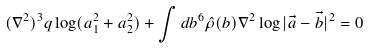<formula> <loc_0><loc_0><loc_500><loc_500>( \nabla ^ { 2 } ) ^ { 3 } q \log ( a _ { 1 } ^ { 2 } + a _ { 2 } ^ { 2 } ) + \int d b ^ { 6 } \hat { \rho } ( b ) \nabla ^ { 2 } \log | \vec { a } - \vec { b } | ^ { 2 } = 0</formula> 